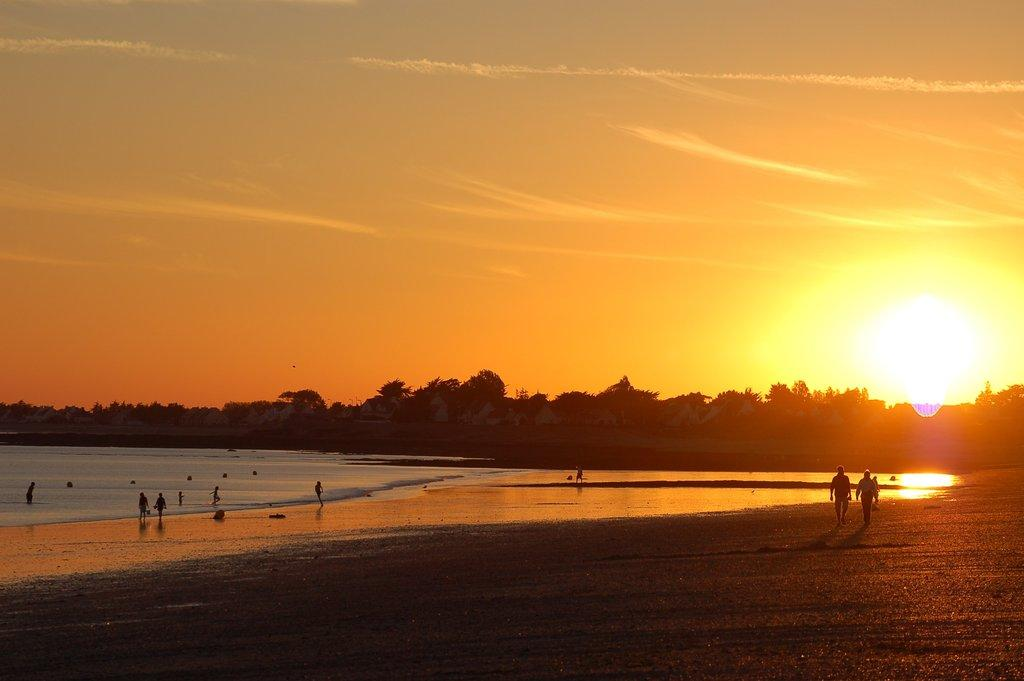What is the surface that the persons are standing on in the image? The persons are on sand in the image. What natural body of water can be seen in the image? There is a sea visible in the image. What type of vegetation is present in the image? There are trees in the image. What is visible in the background of the image? The sky is visible in the background of the image. What atmospheric conditions can be observed in the sky? There are clouds and the sun visible in the sky. What is the price of the horn that is visible in the image? There is no horn present in the image. What grade of sand can be seen in the image? The grade of sand cannot be determined from the image, as it does not provide information about the sand's composition or quality. 